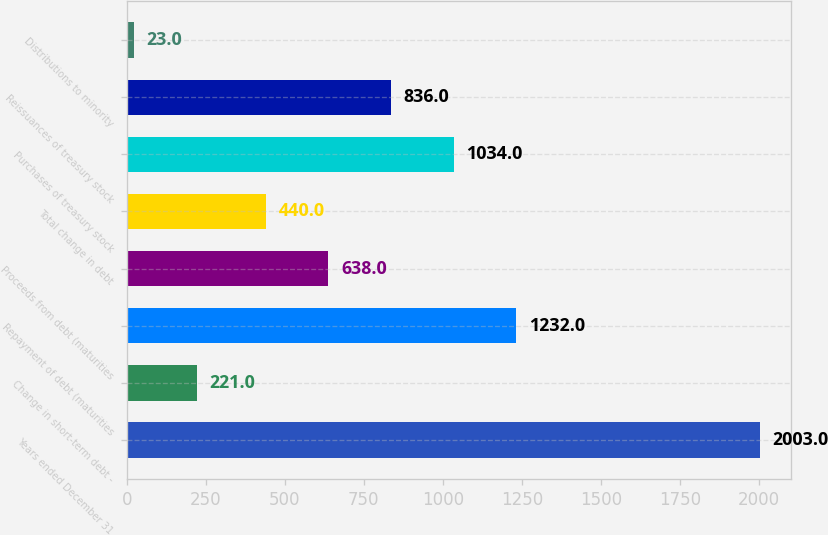Convert chart. <chart><loc_0><loc_0><loc_500><loc_500><bar_chart><fcel>Years ended December 31<fcel>Change in short-term debt -<fcel>Repayment of debt (maturities<fcel>Proceeds from debt (maturities<fcel>Total change in debt<fcel>Purchases of treasury stock<fcel>Reissuances of treasury stock<fcel>Distributions to minority<nl><fcel>2003<fcel>221<fcel>1232<fcel>638<fcel>440<fcel>1034<fcel>836<fcel>23<nl></chart> 